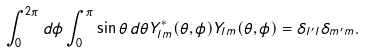Convert formula to latex. <formula><loc_0><loc_0><loc_500><loc_500>\int ^ { 2 \pi } _ { 0 } d \phi \int ^ { \pi } _ { 0 } \sin \theta \, d \theta Y ^ { * } _ { l m } ( \theta , \phi ) Y _ { l m } ( \theta , \phi ) = \delta _ { l ^ { \prime } l } \delta _ { m ^ { \prime } m } .</formula> 